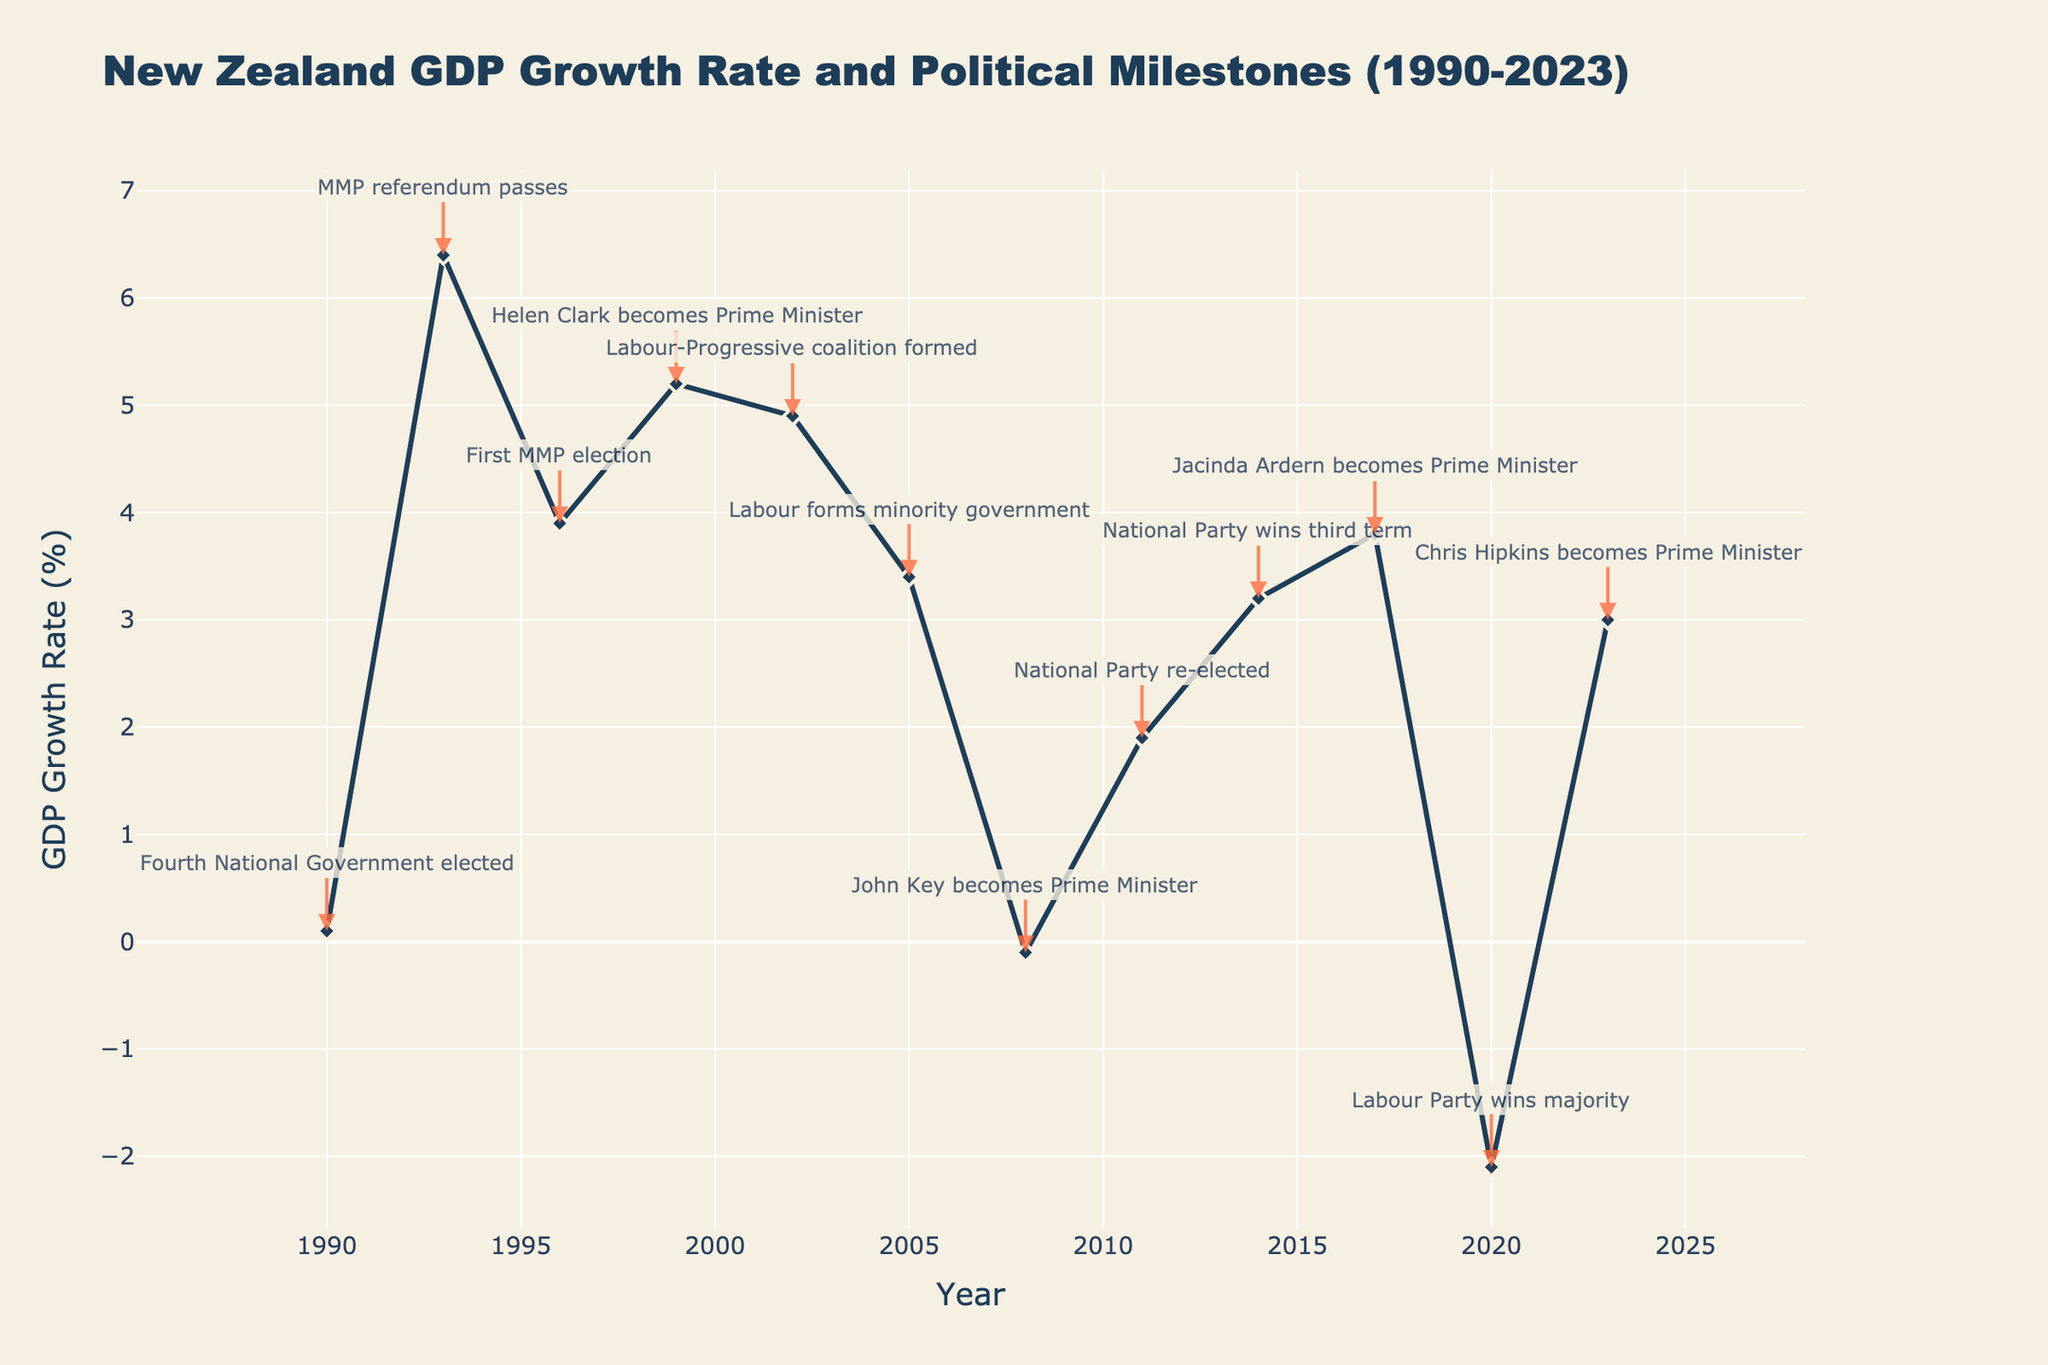When did New Zealand's GDP experience its lowest growth rate between 1990 and 2023? According to the figure, the lowest GDP growth rate occurred in 2020 when it was -2.1%.
Answer: 2020 What was the GDP growth rate when the Labour-Progressive coalition was formed in 2002? The figure shows that the GDP growth rate in 2002 was 4.9%.
Answer: 4.9% Compare the GDP growth rates between the National Party's third term win in 2014 and Labour Party's majority win in 2020. Which was higher? The GDP growth rate was 3.2% in 2014 and -2.1% in 2020. Thus, 2014's GDP growth rate was higher.
Answer: 2014 What was the GDP growth trend from when John Key became Prime Minister in 2008 to when Jacinda Ardern became Prime Minister in 2017? Starting in 2008 with a -0.1% growth rate, the GDP growth increases to 1.9% in 2011, 3.2% in 2014, and finally 3.8% in 2017.
Answer: Increasing trend What is the difference between the GDP growth rates of the first Mixed Member Proportional (MMP) election in 1996 and Helen Clark becoming Prime Minister in 1999? The GDP growth rate in 1996 was 3.9% and in 1999 it was 5.2%. The difference is 5.2% - 3.9% = 1.3%.
Answer: 1.3% Which political milestone corresponded to a negative GDP growth rate? The figure shows two negative growth rates: in 2008 when John Key became Prime Minister (-0.1%) and in 2020 when Labour Party won the majority (-2.1%).
Answer: 2008, 2020 What is the average GDP growth rate during the periods when the National Party was in power from 2008 to 2017? The GDP growth rates are -0.1% (2008), 1.9% (2011), 3.2% (2014), and 3.8% (2017). Average = (-0.1% + 1.9% + 3.2% + 3.8%) / 4 = 8.8% / 4 = 2.2%.
Answer: 2.2% What visual attribute is used to highlight political milestones on the line chart? The figure uses annotations with arrows to highlight political milestones.
Answer: Annotations with arrows 